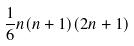Convert formula to latex. <formula><loc_0><loc_0><loc_500><loc_500>\frac { 1 } { 6 } n ( n + 1 ) ( 2 n + 1 )</formula> 